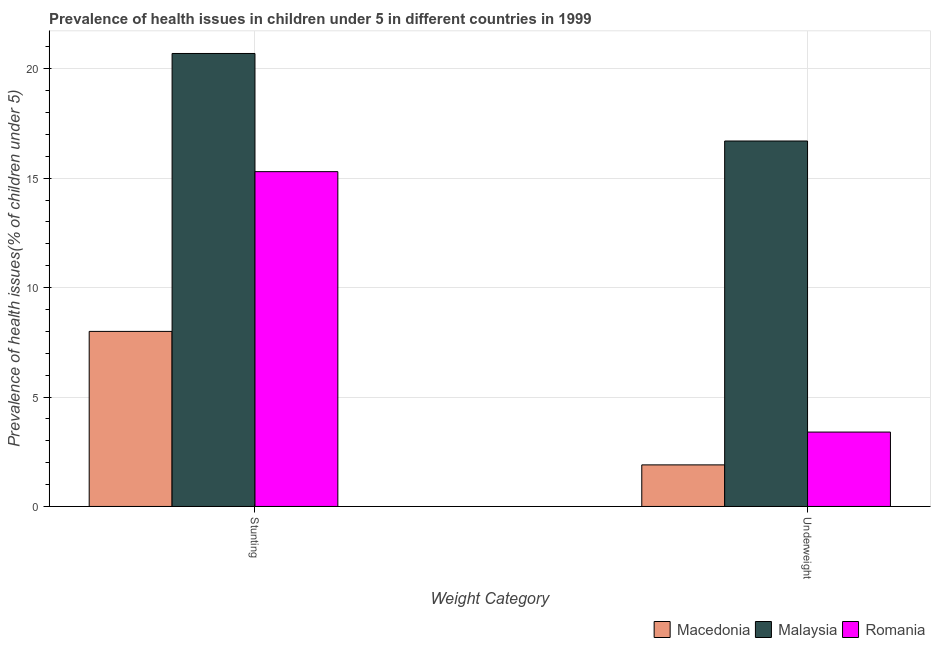How many bars are there on the 1st tick from the left?
Ensure brevity in your answer.  3. What is the label of the 2nd group of bars from the left?
Give a very brief answer. Underweight. What is the percentage of stunted children in Malaysia?
Give a very brief answer. 20.7. Across all countries, what is the maximum percentage of underweight children?
Offer a very short reply. 16.7. Across all countries, what is the minimum percentage of stunted children?
Ensure brevity in your answer.  8. In which country was the percentage of underweight children maximum?
Your response must be concise. Malaysia. In which country was the percentage of stunted children minimum?
Your answer should be very brief. Macedonia. What is the total percentage of stunted children in the graph?
Make the answer very short. 44. What is the difference between the percentage of stunted children in Macedonia and that in Malaysia?
Your response must be concise. -12.7. What is the difference between the percentage of stunted children in Romania and the percentage of underweight children in Malaysia?
Offer a terse response. -1.4. What is the average percentage of stunted children per country?
Your answer should be very brief. 14.67. What is the difference between the percentage of stunted children and percentage of underweight children in Romania?
Make the answer very short. 11.9. In how many countries, is the percentage of stunted children greater than 17 %?
Your answer should be compact. 1. What is the ratio of the percentage of underweight children in Macedonia to that in Malaysia?
Keep it short and to the point. 0.11. Is the percentage of stunted children in Macedonia less than that in Malaysia?
Offer a terse response. Yes. In how many countries, is the percentage of stunted children greater than the average percentage of stunted children taken over all countries?
Ensure brevity in your answer.  2. What does the 1st bar from the left in Underweight represents?
Make the answer very short. Macedonia. What does the 1st bar from the right in Underweight represents?
Keep it short and to the point. Romania. Does the graph contain grids?
Keep it short and to the point. Yes. Where does the legend appear in the graph?
Offer a terse response. Bottom right. What is the title of the graph?
Keep it short and to the point. Prevalence of health issues in children under 5 in different countries in 1999. What is the label or title of the X-axis?
Offer a terse response. Weight Category. What is the label or title of the Y-axis?
Provide a succinct answer. Prevalence of health issues(% of children under 5). What is the Prevalence of health issues(% of children under 5) of Malaysia in Stunting?
Keep it short and to the point. 20.7. What is the Prevalence of health issues(% of children under 5) of Romania in Stunting?
Make the answer very short. 15.3. What is the Prevalence of health issues(% of children under 5) of Macedonia in Underweight?
Offer a very short reply. 1.9. What is the Prevalence of health issues(% of children under 5) in Malaysia in Underweight?
Ensure brevity in your answer.  16.7. What is the Prevalence of health issues(% of children under 5) of Romania in Underweight?
Offer a terse response. 3.4. Across all Weight Category, what is the maximum Prevalence of health issues(% of children under 5) of Macedonia?
Ensure brevity in your answer.  8. Across all Weight Category, what is the maximum Prevalence of health issues(% of children under 5) of Malaysia?
Give a very brief answer. 20.7. Across all Weight Category, what is the maximum Prevalence of health issues(% of children under 5) in Romania?
Your answer should be very brief. 15.3. Across all Weight Category, what is the minimum Prevalence of health issues(% of children under 5) in Macedonia?
Provide a short and direct response. 1.9. Across all Weight Category, what is the minimum Prevalence of health issues(% of children under 5) of Malaysia?
Provide a short and direct response. 16.7. Across all Weight Category, what is the minimum Prevalence of health issues(% of children under 5) in Romania?
Give a very brief answer. 3.4. What is the total Prevalence of health issues(% of children under 5) of Malaysia in the graph?
Offer a terse response. 37.4. What is the difference between the Prevalence of health issues(% of children under 5) of Macedonia in Stunting and that in Underweight?
Keep it short and to the point. 6.1. What is the difference between the Prevalence of health issues(% of children under 5) in Romania in Stunting and that in Underweight?
Provide a succinct answer. 11.9. What is the difference between the Prevalence of health issues(% of children under 5) in Macedonia in Stunting and the Prevalence of health issues(% of children under 5) in Malaysia in Underweight?
Keep it short and to the point. -8.7. What is the difference between the Prevalence of health issues(% of children under 5) in Macedonia in Stunting and the Prevalence of health issues(% of children under 5) in Romania in Underweight?
Your answer should be compact. 4.6. What is the difference between the Prevalence of health issues(% of children under 5) of Malaysia in Stunting and the Prevalence of health issues(% of children under 5) of Romania in Underweight?
Ensure brevity in your answer.  17.3. What is the average Prevalence of health issues(% of children under 5) of Macedonia per Weight Category?
Give a very brief answer. 4.95. What is the average Prevalence of health issues(% of children under 5) of Romania per Weight Category?
Offer a terse response. 9.35. What is the difference between the Prevalence of health issues(% of children under 5) of Macedonia and Prevalence of health issues(% of children under 5) of Malaysia in Stunting?
Your response must be concise. -12.7. What is the difference between the Prevalence of health issues(% of children under 5) of Malaysia and Prevalence of health issues(% of children under 5) of Romania in Stunting?
Your answer should be compact. 5.4. What is the difference between the Prevalence of health issues(% of children under 5) of Macedonia and Prevalence of health issues(% of children under 5) of Malaysia in Underweight?
Your answer should be compact. -14.8. What is the difference between the Prevalence of health issues(% of children under 5) in Macedonia and Prevalence of health issues(% of children under 5) in Romania in Underweight?
Your answer should be very brief. -1.5. What is the difference between the Prevalence of health issues(% of children under 5) in Malaysia and Prevalence of health issues(% of children under 5) in Romania in Underweight?
Your response must be concise. 13.3. What is the ratio of the Prevalence of health issues(% of children under 5) in Macedonia in Stunting to that in Underweight?
Make the answer very short. 4.21. What is the ratio of the Prevalence of health issues(% of children under 5) of Malaysia in Stunting to that in Underweight?
Offer a terse response. 1.24. What is the difference between the highest and the second highest Prevalence of health issues(% of children under 5) of Romania?
Your answer should be very brief. 11.9. What is the difference between the highest and the lowest Prevalence of health issues(% of children under 5) in Macedonia?
Provide a succinct answer. 6.1. What is the difference between the highest and the lowest Prevalence of health issues(% of children under 5) of Malaysia?
Make the answer very short. 4. What is the difference between the highest and the lowest Prevalence of health issues(% of children under 5) of Romania?
Ensure brevity in your answer.  11.9. 